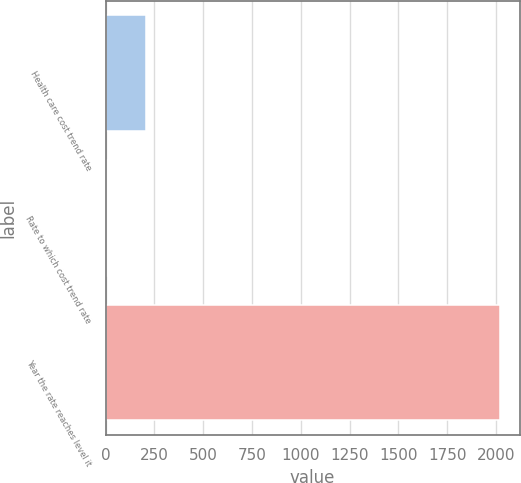Convert chart to OTSL. <chart><loc_0><loc_0><loc_500><loc_500><bar_chart><fcel>Health care cost trend rate<fcel>Rate to which cost trend rate<fcel>Year the rate reaches level it<nl><fcel>206.5<fcel>5<fcel>2020<nl></chart> 